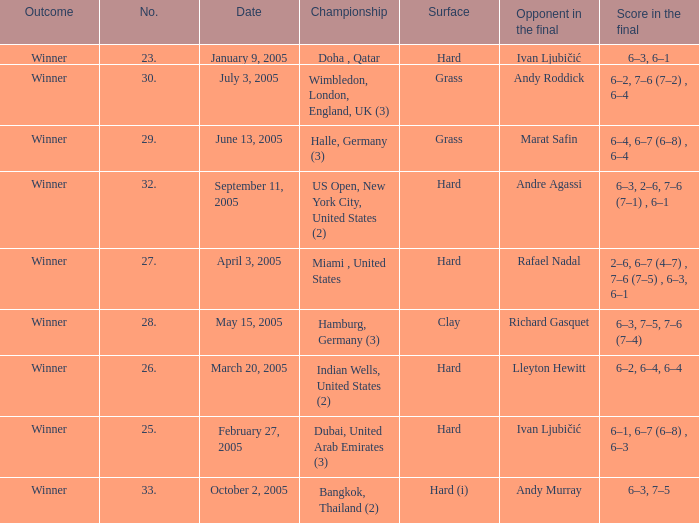Marat Safin is the opponent in the final in what championship? Halle, Germany (3). 